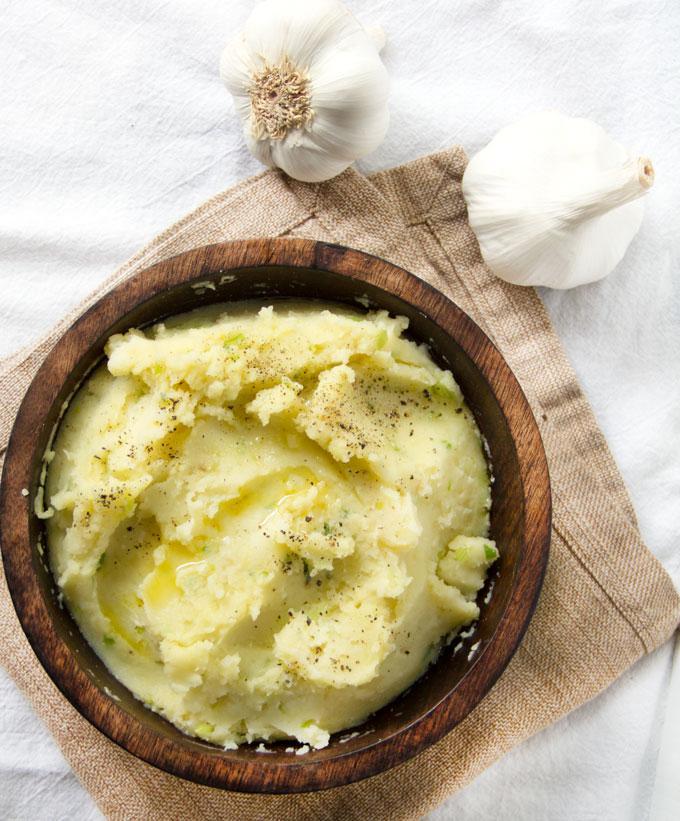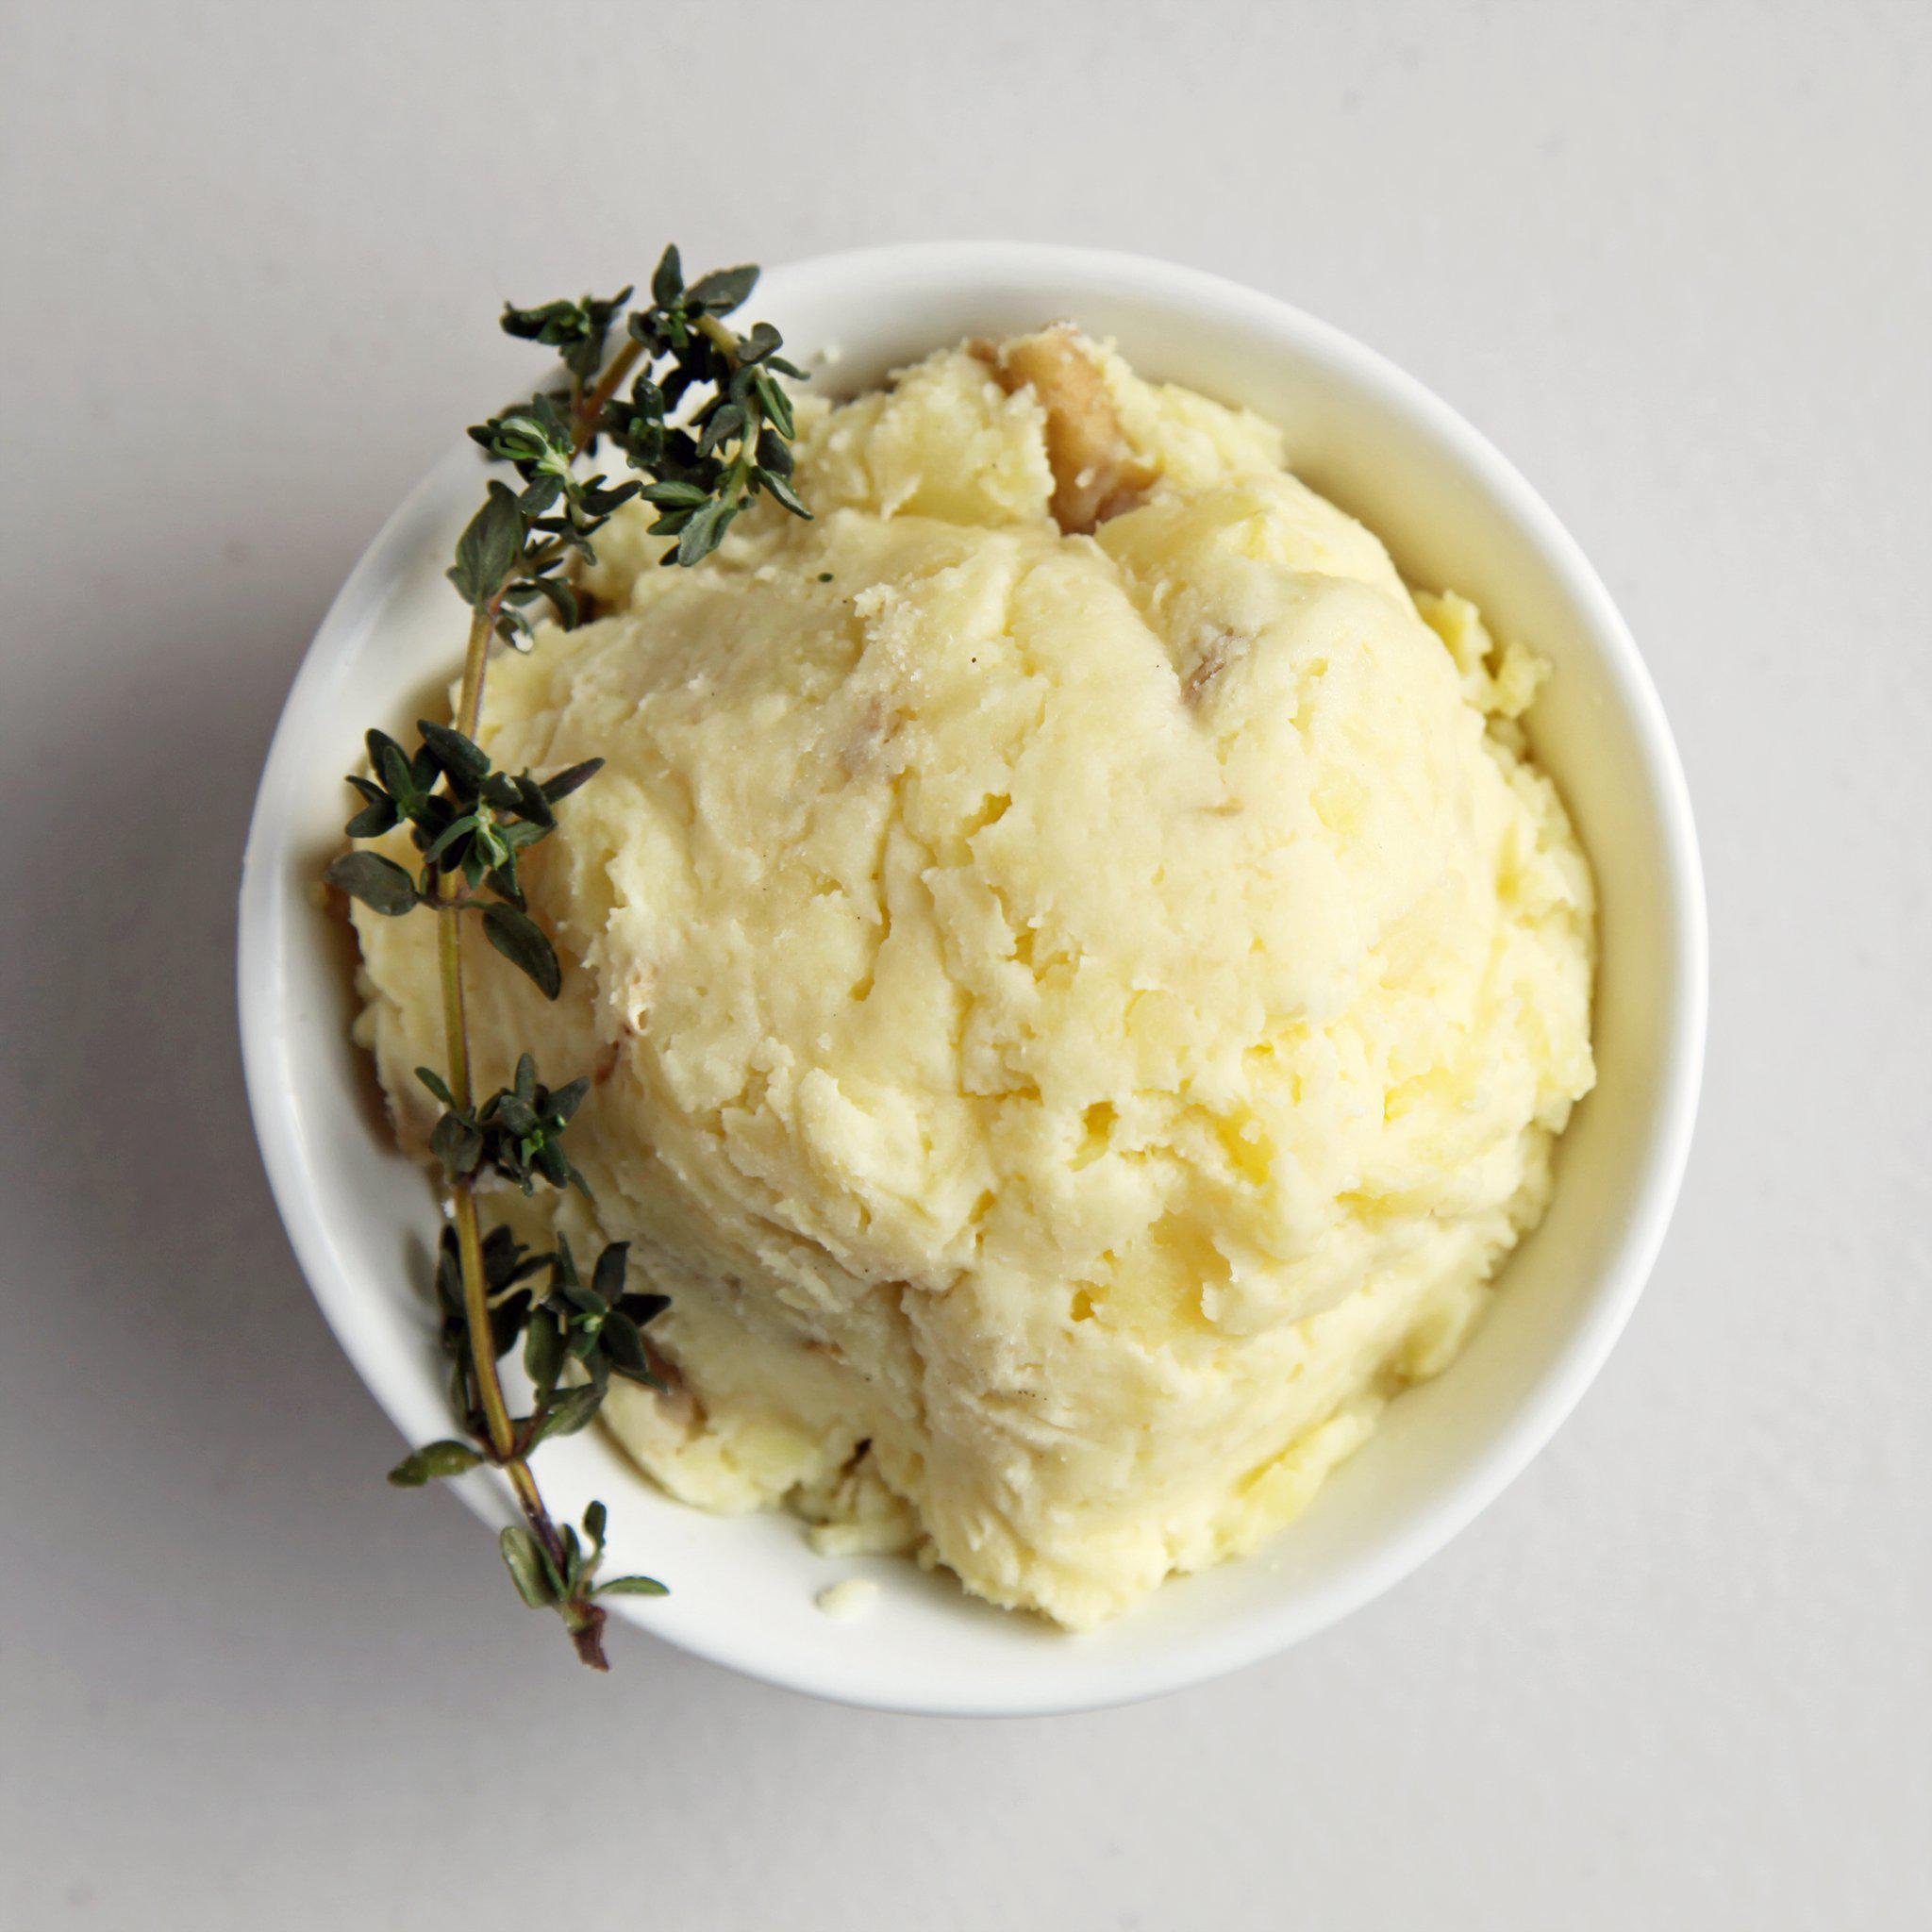The first image is the image on the left, the second image is the image on the right. Analyze the images presented: Is the assertion "Cloves of garlic are above one of the bowls of mashed potatoes." valid? Answer yes or no. Yes. The first image is the image on the left, the second image is the image on the right. Evaluate the accuracy of this statement regarding the images: "The left image shows finely chopped green herbs sprinkled across the top of the mashed potatoes.". Is it true? Answer yes or no. No. 